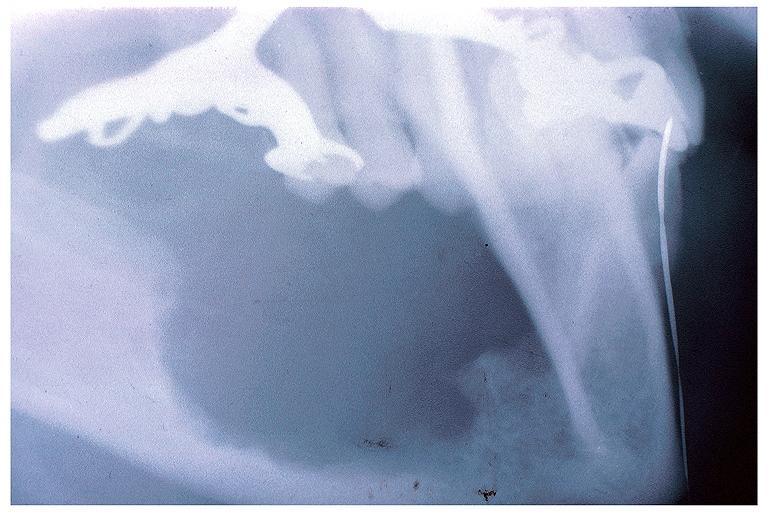s an opened peritoneal cavity cause by fibrous band strangulation present?
Answer the question using a single word or phrase. No 